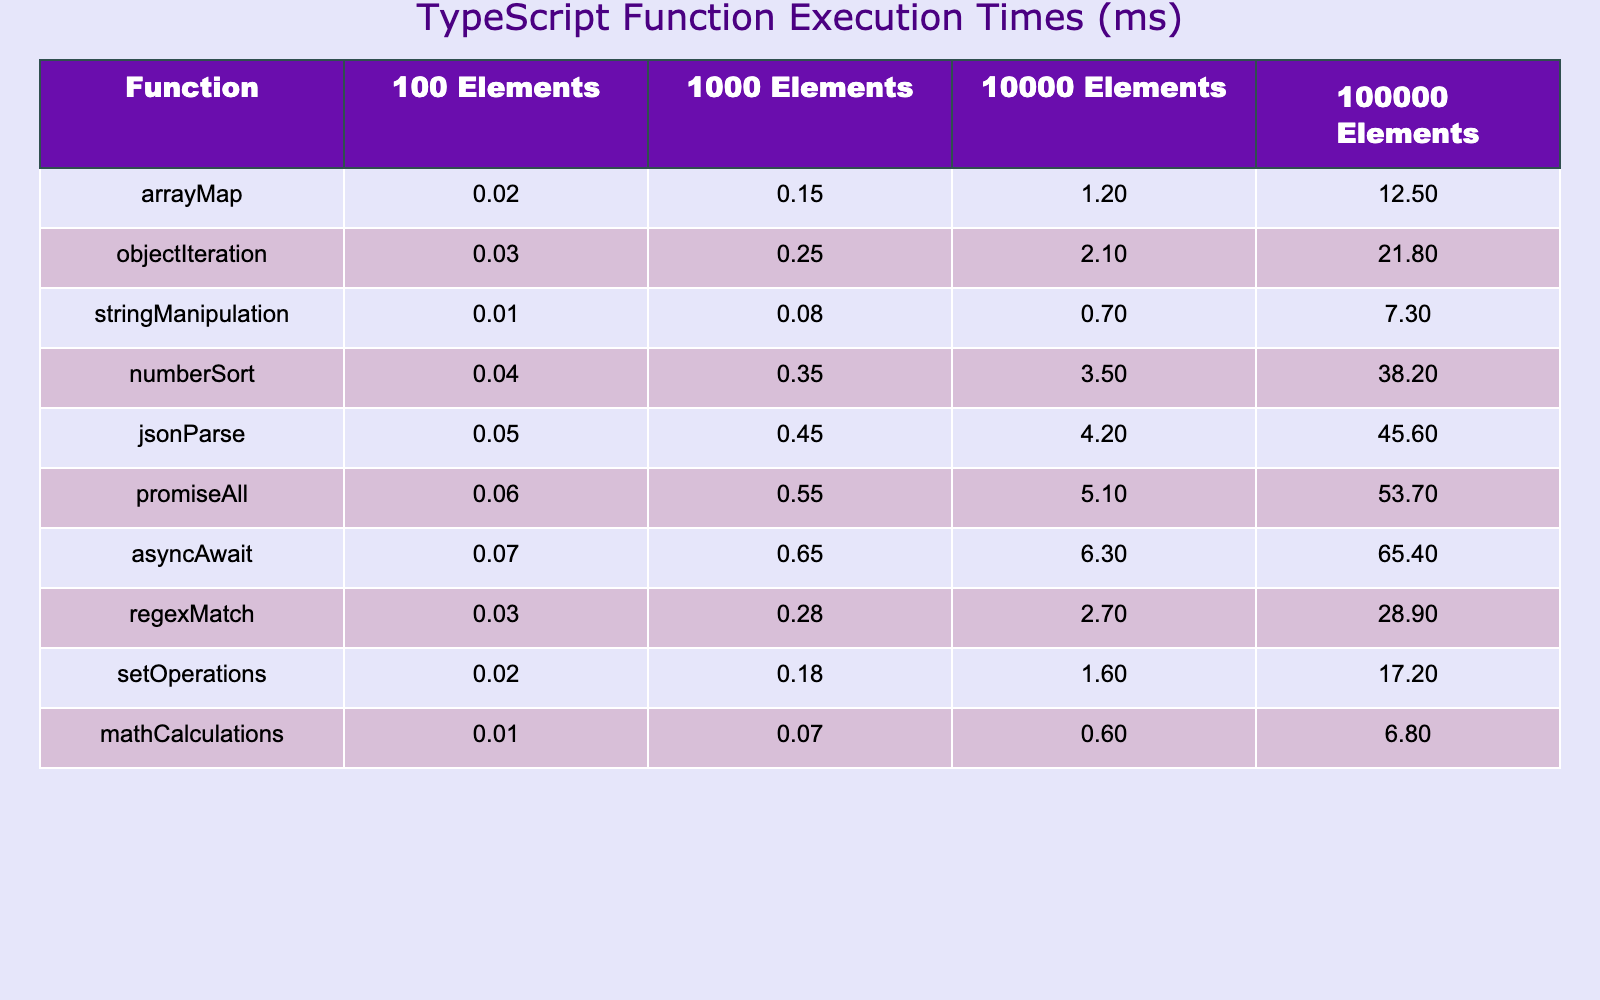What is the execution time for the `arrayMap` function with 10,000 elements? According to the table, the execution time for the `arrayMap` function with 10,000 elements is 1.2 ms.
Answer: 1.2 ms Which function has the longest execution time with 100,000 elements? The table shows that the `numberSort` function has the longest execution time with 100,000 elements at 38.2 ms.
Answer: numberSort What is the average execution time for functions with 100 elements? The execution times for functions with 100 elements are: arrayMap (0.02), objectIteration (0.03), stringManipulation (0.01), numberSort (0.04), jsonParse (0.05), promiseAll (0.06), asyncAwait (0.07), regexMatch (0.03), setOperations (0.02), and mathCalculations (0.01). The sum is 0.02 + 0.03 + 0.01 + 0.04 + 0.05 + 0.06 + 0.07 + 0.03 + 0.02 + 0.01 = 0.34 ms, and dividing by 10 gives an average of 0.034 ms.
Answer: 0.034 ms Is the execution time for `jsonParse` greater than that for `stringManipulation` with 1,000 elements? The table shows the execution time for `jsonParse` is 0.45 ms and for `stringManipulation` is 0.08 ms. Since 0.45 is greater than 0.08, the answer is yes.
Answer: Yes What is the difference in execution time between `promiseAll` and `setOperations` for 100,000 elements? The execution time for `promiseAll` is 53.7 ms and for `setOperations` is 17.2 ms. The difference is calculated as 53.7 - 17.2 = 36.5 ms.
Answer: 36.5 ms Which function demonstrates the least increase in execution time when scaling from 1,000 to 100,000 elements? By comparing the increases, we have: `mathCalculations` increases from 0.07 to 6.8 (6.73 ms), `stringManipulation` increases from 0.08 to 7.3 (7.22 ms), and so on. The `mathCalculations` function shows the least increase of 6.73 ms.
Answer: mathCalculations How does the execution time of `asyncAwait` change as the data size increases from 100 to 100,000 elements? The execution time starts at 0.07 ms for 100 elements and increases to 65.4 ms for 100,000 elements. This is a total increase of 65.4 - 0.07 = 65.33 ms, showing a significant increase as the data size grows.
Answer: Increases by 65.33 ms Which function's execution time shows the smallest value at the 100 elements data size and what is that value? At the 100 elements data size, `stringManipulation` has the smallest execution time of 0.01 ms.
Answer: stringManipulation, 0.01 ms Are `arrayMap` and `mathCalculations` execution times equal when considering 1,000 elements? At the 1,000 elements data size, `arrayMap` has an execution time of 0.15 ms and `mathCalculations` has 0.07 ms. Since these two values are not equal, the answer is no.
Answer: No What is the order of functions based on their execution time for 100,000 elements from highest to lowest? The execution times for 100,000 elements are: numberSort (38.2), jsonParse (45.6), promiseAll (53.7), asyncAwait (65.4), and so on. The complete order from highest to lowest is: asyncAwait, promiseAll, jsonParse, numberSort, objectIteration, regexMatch, setOperations, arrayMap, stringManipulation, mathCalculations.
Answer: asyncAwait, promiseAll, jsonParse, numberSort, objectIteration, regexMatch, setOperations, arrayMap, stringManipulation, mathCalculations 